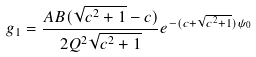<formula> <loc_0><loc_0><loc_500><loc_500>g _ { 1 } = \frac { A B ( \sqrt { c ^ { 2 } + 1 } - c ) } { 2 Q ^ { 2 } \sqrt { c ^ { 2 } + 1 } } e ^ { - ( c + \sqrt { c ^ { 2 } + 1 } ) \psi _ { 0 } }</formula> 